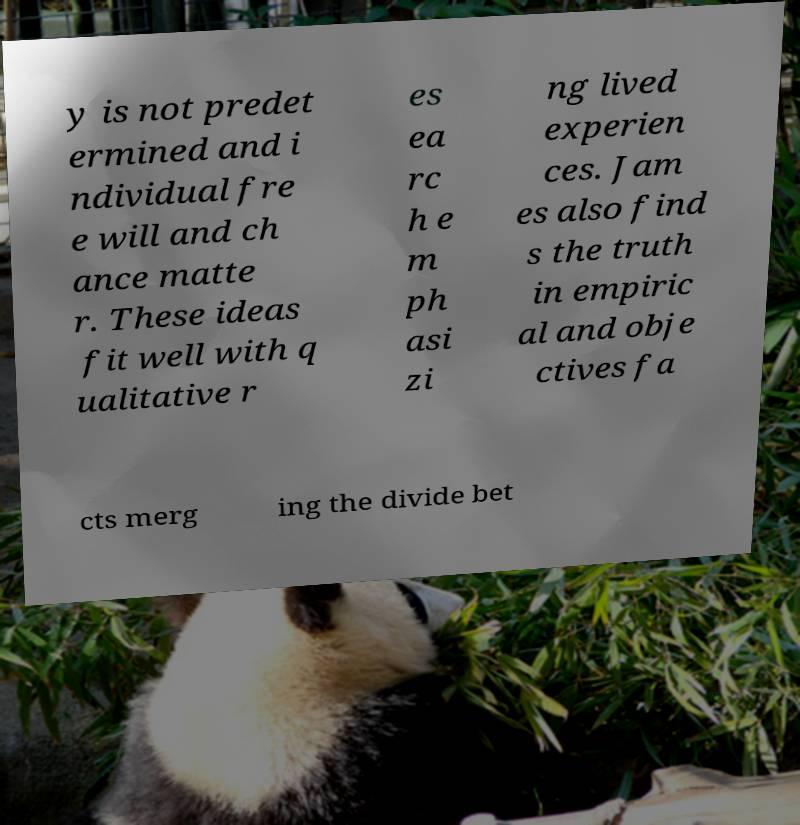Please identify and transcribe the text found in this image. y is not predet ermined and i ndividual fre e will and ch ance matte r. These ideas fit well with q ualitative r es ea rc h e m ph asi zi ng lived experien ces. Jam es also find s the truth in empiric al and obje ctives fa cts merg ing the divide bet 